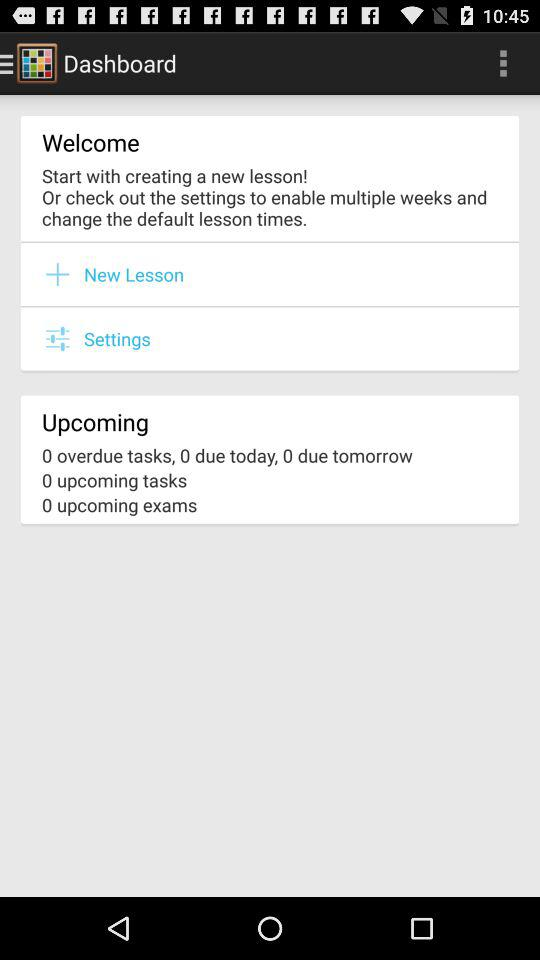How many tasks are due tomorrow?
Answer the question using a single word or phrase. 0 